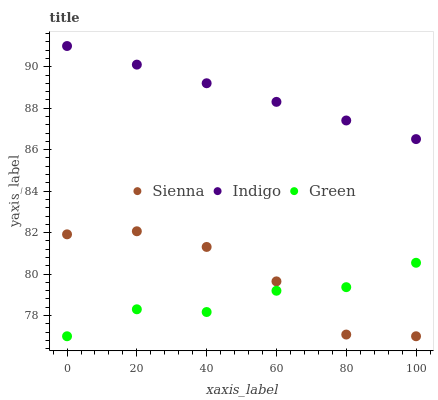Does Green have the minimum area under the curve?
Answer yes or no. Yes. Does Indigo have the maximum area under the curve?
Answer yes or no. Yes. Does Indigo have the minimum area under the curve?
Answer yes or no. No. Does Green have the maximum area under the curve?
Answer yes or no. No. Is Indigo the smoothest?
Answer yes or no. Yes. Is Sienna the roughest?
Answer yes or no. Yes. Is Green the smoothest?
Answer yes or no. No. Is Green the roughest?
Answer yes or no. No. Does Sienna have the lowest value?
Answer yes or no. Yes. Does Indigo have the lowest value?
Answer yes or no. No. Does Indigo have the highest value?
Answer yes or no. Yes. Does Green have the highest value?
Answer yes or no. No. Is Green less than Indigo?
Answer yes or no. Yes. Is Indigo greater than Green?
Answer yes or no. Yes. Does Sienna intersect Green?
Answer yes or no. Yes. Is Sienna less than Green?
Answer yes or no. No. Is Sienna greater than Green?
Answer yes or no. No. Does Green intersect Indigo?
Answer yes or no. No. 